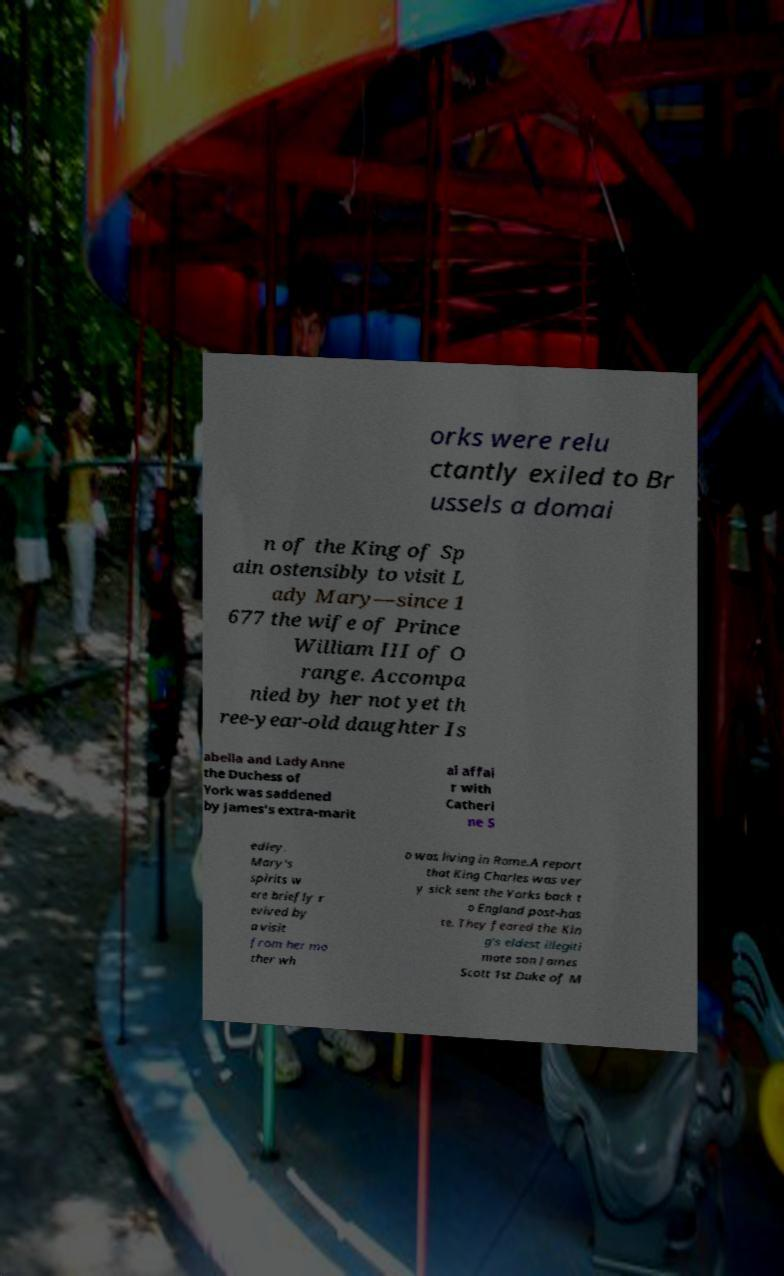There's text embedded in this image that I need extracted. Can you transcribe it verbatim? orks were relu ctantly exiled to Br ussels a domai n of the King of Sp ain ostensibly to visit L ady Mary—since 1 677 the wife of Prince William III of O range. Accompa nied by her not yet th ree-year-old daughter Is abella and Lady Anne the Duchess of York was saddened by James's extra-marit al affai r with Catheri ne S edley. Mary's spirits w ere briefly r evived by a visit from her mo ther wh o was living in Rome.A report that King Charles was ver y sick sent the Yorks back t o England post-has te. They feared the Kin g's eldest illegiti mate son James Scott 1st Duke of M 